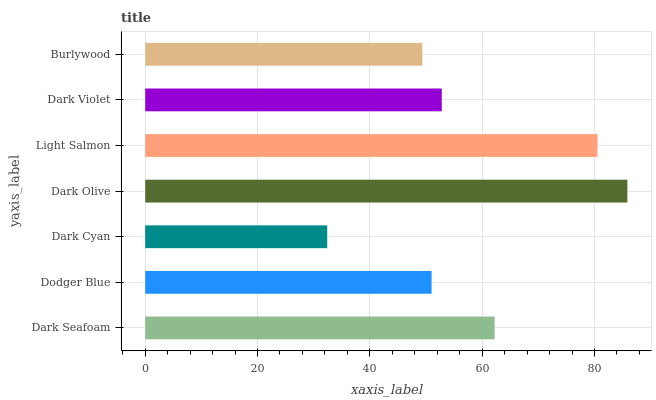Is Dark Cyan the minimum?
Answer yes or no. Yes. Is Dark Olive the maximum?
Answer yes or no. Yes. Is Dodger Blue the minimum?
Answer yes or no. No. Is Dodger Blue the maximum?
Answer yes or no. No. Is Dark Seafoam greater than Dodger Blue?
Answer yes or no. Yes. Is Dodger Blue less than Dark Seafoam?
Answer yes or no. Yes. Is Dodger Blue greater than Dark Seafoam?
Answer yes or no. No. Is Dark Seafoam less than Dodger Blue?
Answer yes or no. No. Is Dark Violet the high median?
Answer yes or no. Yes. Is Dark Violet the low median?
Answer yes or no. Yes. Is Light Salmon the high median?
Answer yes or no. No. Is Dark Seafoam the low median?
Answer yes or no. No. 